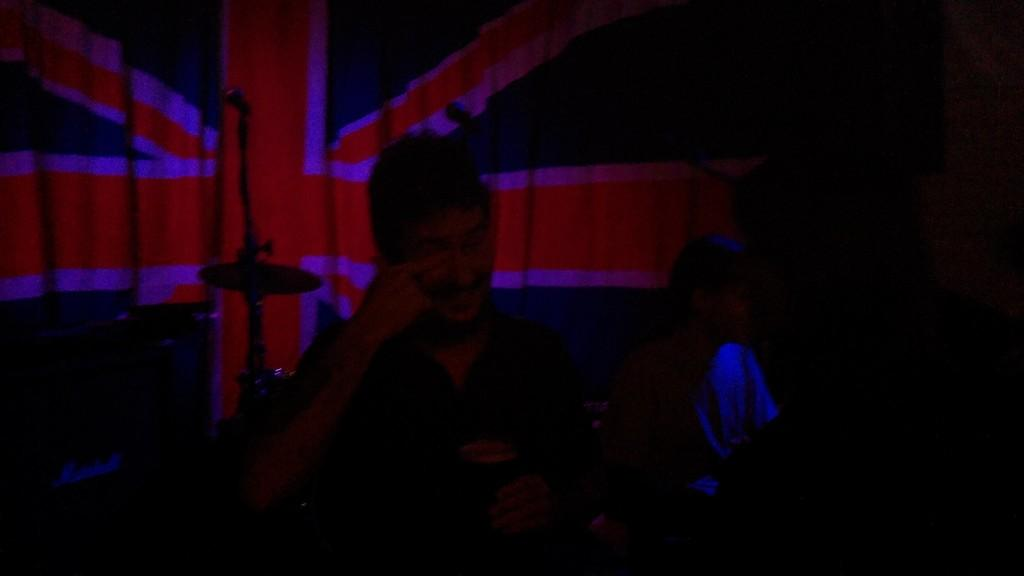What is the lighting condition in the image? The image was taken in the dark. How many people are in the image? There are two persons in the image. What can be seen on the left side of the image? There is an object on the left side of the image. What is visible in the background of the image? There is a flag in the background of the image. What subject are the two persons teaching in the image? There is no indication in the image that the two persons are teaching any subject. 